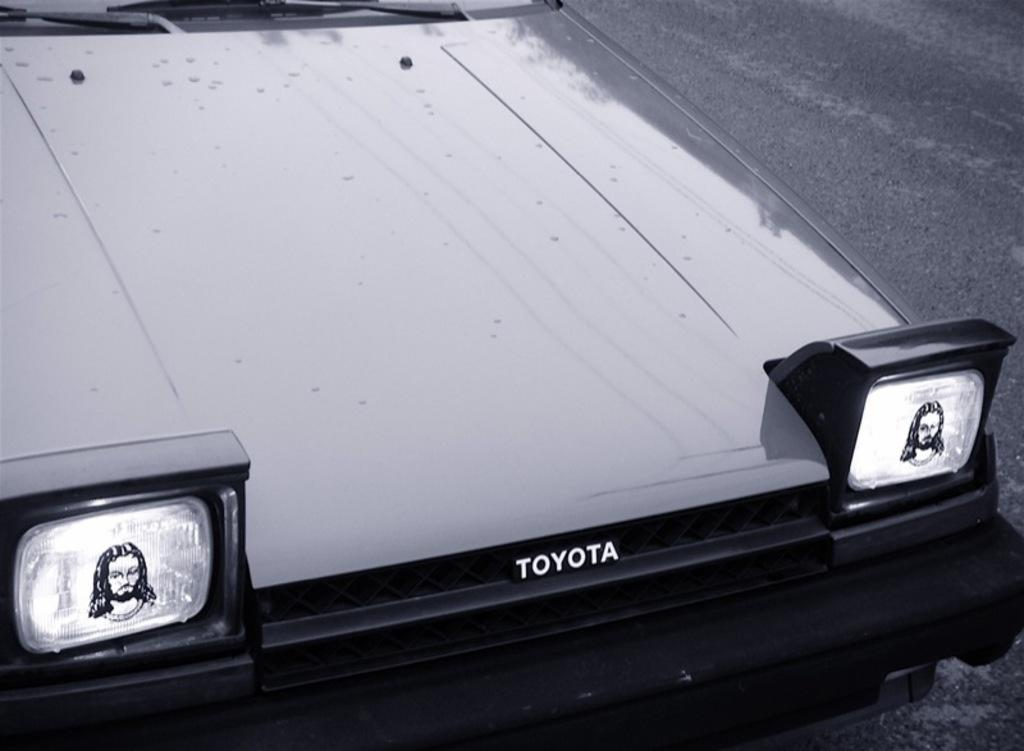What is the main subject of the image? The main subject of the image is a car. Where is the car located in the image? The car is on the road in the image. How many headlights are on the car? There are two headlights on the car. What is unique about the car's headlights? There is a sticker of Jesus on the car's headlights. What type of songs can be heard coming from the car's speakers in the image? There is no information about the car's speakers or the music being played in the image, so it cannot be determined. 